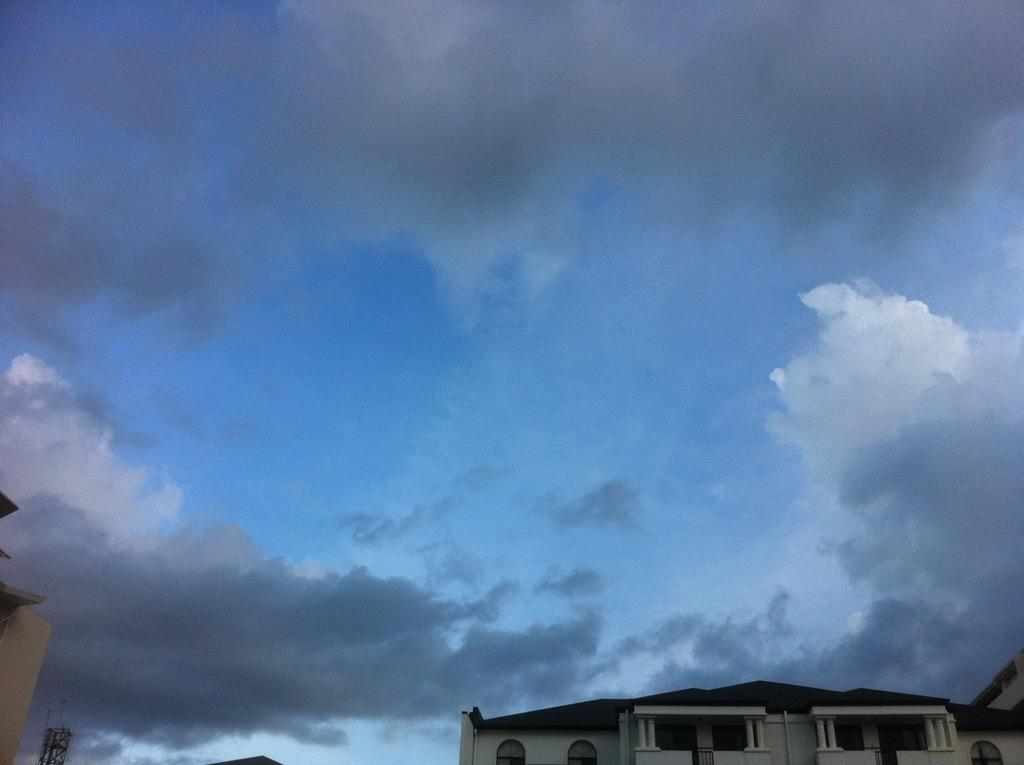What type of structure is present in the image? There is a building in the image. What can be seen in the background of the image? There is a sky visible in the background of the image. What is the condition of the sky in the image? There are clouds in the sky. What type of pan can be seen on the plate in the image? There is no pan or plate present in the image; it only features a building and clouds in the sky. 